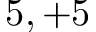Convert formula to latex. <formula><loc_0><loc_0><loc_500><loc_500>5 , + 5</formula> 